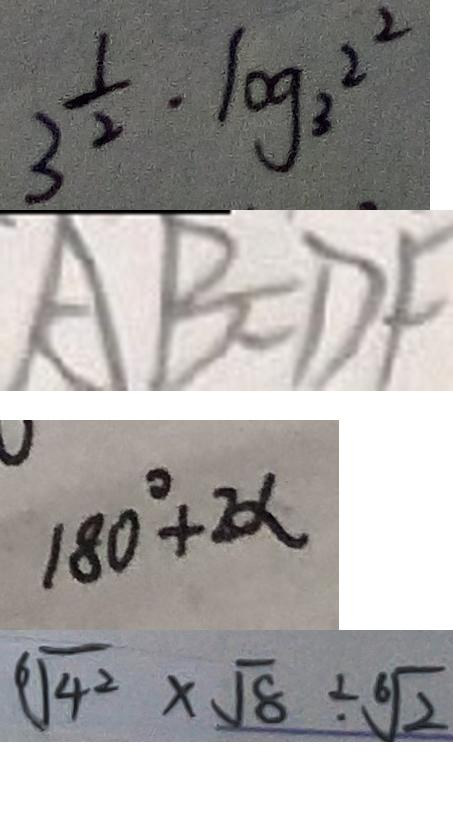Convert formula to latex. <formula><loc_0><loc_0><loc_500><loc_500>3 ^ { \frac { 1 } { 2 } } \cdot \log _ { 3 } ^ { 2 ^ { 2 } } 
 A B = D F 
 1 8 0 ^ { \circ } + 2 \alpha 
 \sqrt [ 6 ] { 4 ^ { 2 } } \times \sqrt { 8 } \div \sqrt [ 6 ] { 2 }</formula> 